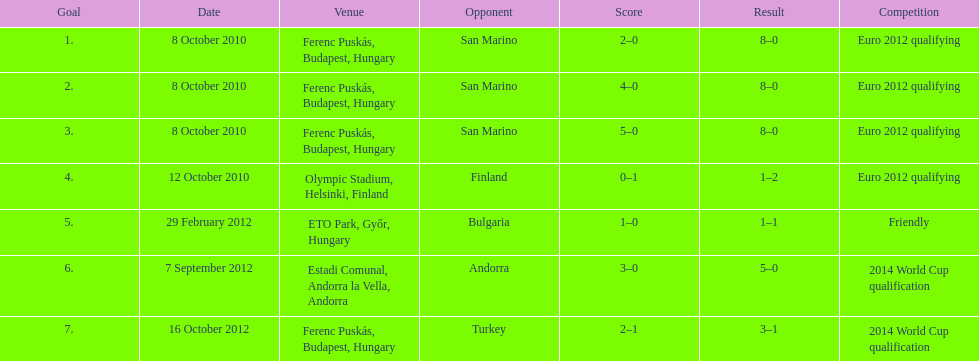In which match did ádám szalai achieve his first international goal? 8 October 2010. 